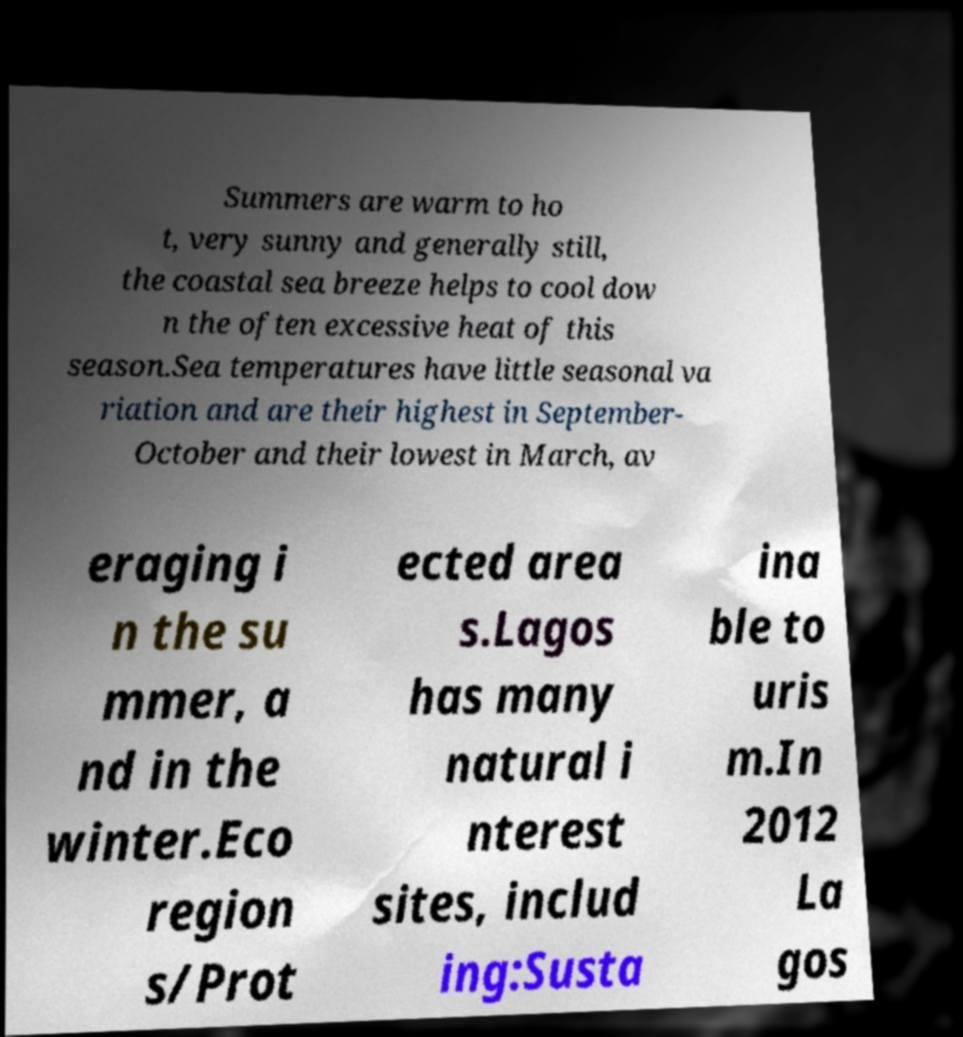Can you accurately transcribe the text from the provided image for me? Summers are warm to ho t, very sunny and generally still, the coastal sea breeze helps to cool dow n the often excessive heat of this season.Sea temperatures have little seasonal va riation and are their highest in September- October and their lowest in March, av eraging i n the su mmer, a nd in the winter.Eco region s/Prot ected area s.Lagos has many natural i nterest sites, includ ing:Susta ina ble to uris m.In 2012 La gos 